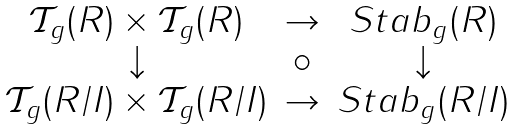<formula> <loc_0><loc_0><loc_500><loc_500>\begin{array} { c c c } \mathcal { T } _ { g } ( R ) \times \mathcal { T } _ { g } ( R ) & \rightarrow & S t a b _ { g } ( R ) \\ \downarrow & \circ & \downarrow \\ \mathcal { T } _ { g } ( R / I ) \times \mathcal { T } _ { g } ( R / I ) & \rightarrow & S t a b _ { g } ( R / I ) \end{array}</formula> 